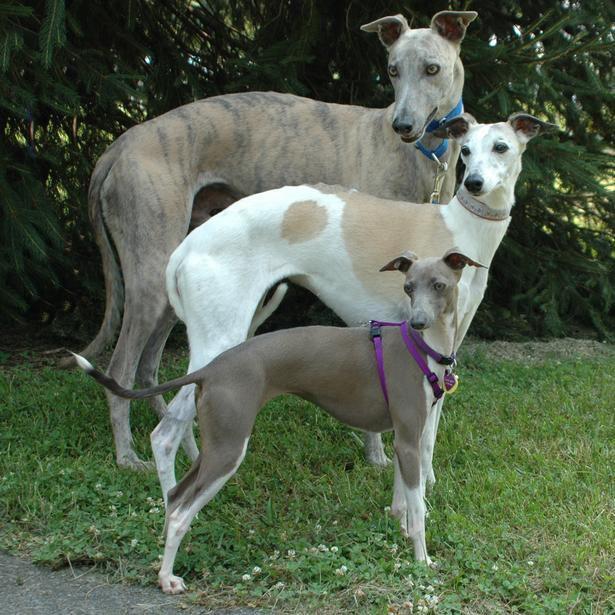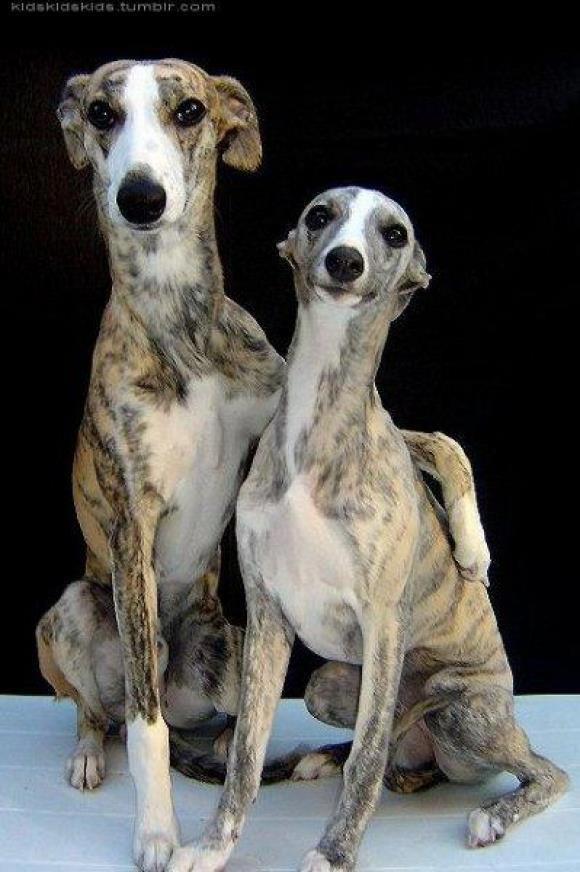The first image is the image on the left, the second image is the image on the right. Examine the images to the left and right. Is the description "An image shows two similarly colored, non-standing dogs side-by-side." accurate? Answer yes or no. Yes. The first image is the image on the left, the second image is the image on the right. For the images shown, is this caption "There are 4 or more dogs, and at least two of them are touching." true? Answer yes or no. Yes. 